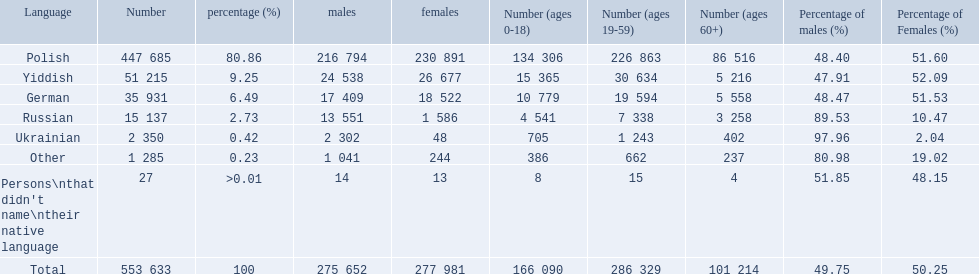What was the least spoken language Ukrainian. What was the most spoken? Polish. 